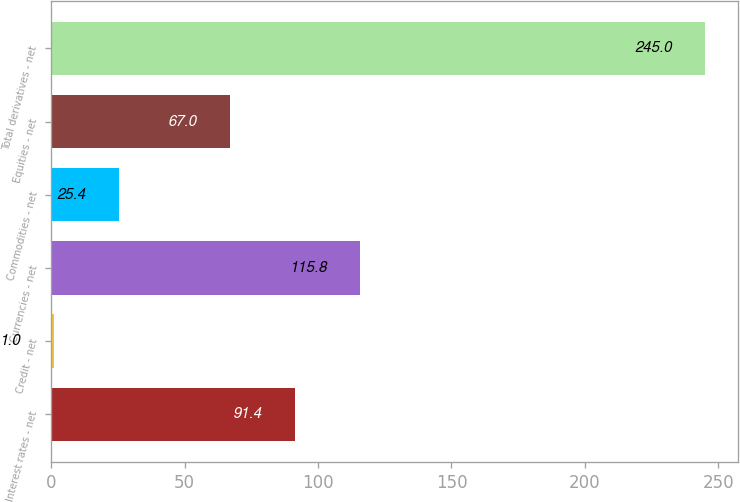Convert chart to OTSL. <chart><loc_0><loc_0><loc_500><loc_500><bar_chart><fcel>Interest rates - net<fcel>Credit - net<fcel>Currencies - net<fcel>Commodities - net<fcel>Equities - net<fcel>Total derivatives - net<nl><fcel>91.4<fcel>1<fcel>115.8<fcel>25.4<fcel>67<fcel>245<nl></chart> 